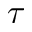Convert formula to latex. <formula><loc_0><loc_0><loc_500><loc_500>\tau</formula> 